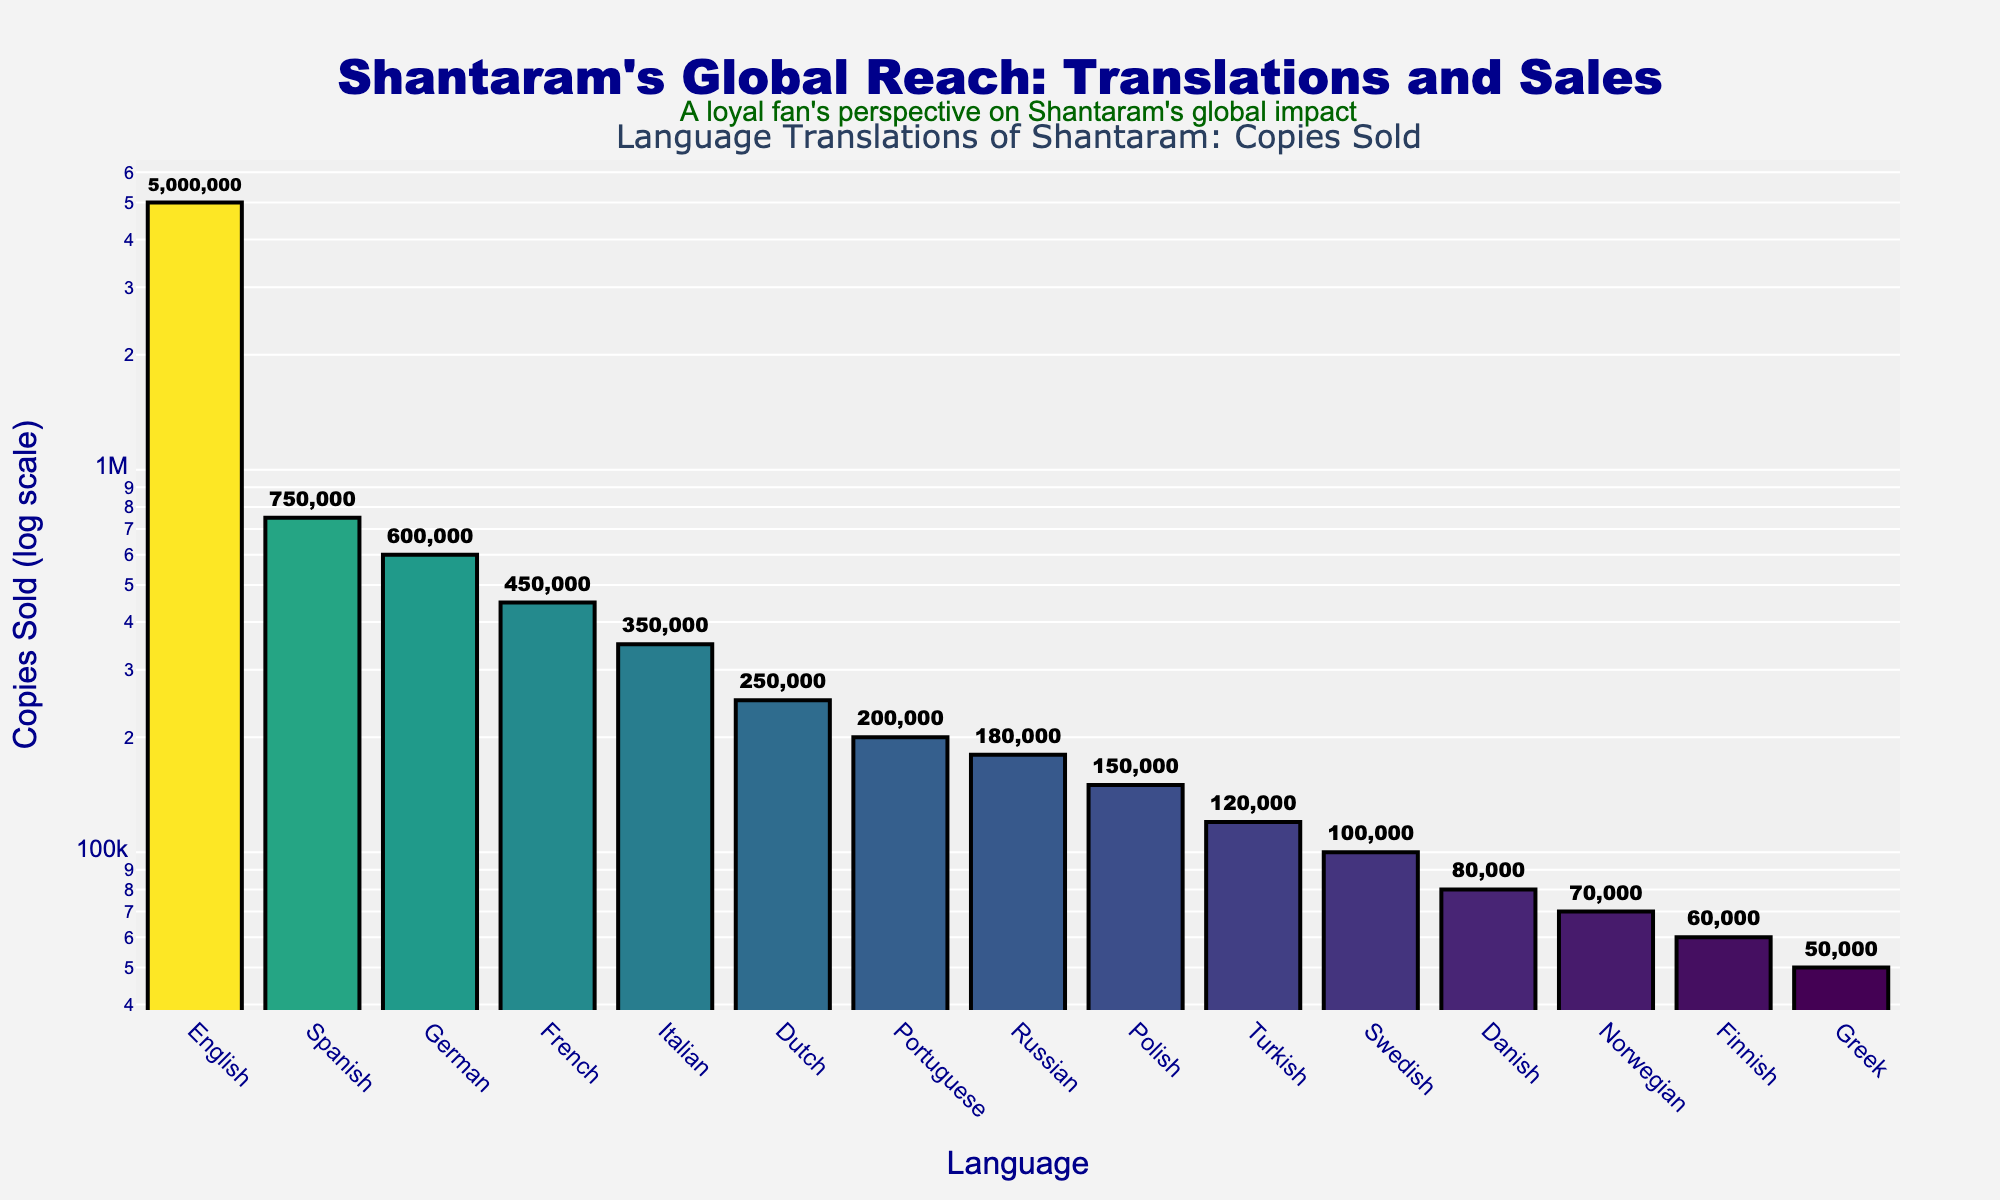What language translation of Shantaram sold the most copies? Look for the bar with the greatest height in the chart and identify the corresponding language.
Answer: English Which language translation sold the least copies? Identify the bar with the shortest height and note the language associated with it.
Answer: Greek How many more copies did the Spanish translation sell compared to the Russian translation? Find the height of the Spanish and Russian bars and subtract the Russian figure from the Spanish figure: 750,000 - 180,000.
Answer: 570,000 What is the total number of copies sold across the top three languages? Sum the copies sold in the top three bars: English (5,000,000), Spanish (750,000), and German (600,000). Calculate 5,000,000 + 750,000 + 600,000.
Answer: 6,350,000 Between Italian and Portuguese translations, which sold more copies, and by how much? Compare the heights of the Italian and Portuguese bars. Italian sold 350,000 copies, and Portuguese sold 200,000 copies. Subtract Portuguese from Italian: 350,000 - 200,000.
Answer: Italian by 150,000 What’s the average number of copies sold for the translations in languages other than English? Sum the copies sold for all languages except English and divide by the number of those languages (14 languages). (5,000,000 excluded, total for others = 750,000 + 600,000 + 450,000 + 350,000 + 250,000 + 200,000 + 180,000 + 150,000 + 120,000 + 100,000 + 80,000 + 70,000 + 60,000 + 50,000 = 3,410,000). Now, 3,410,000 / 14.
Answer: 243,571 What is the median number of copies sold for all language translations? Arrange the number of copies sold in ascending order and find the middle value. With 15 data points, the median will be the 8th value once sorted.
Answer: 180,000 Which language translations sold between 100,000 and 300,000 copies? Identify the bars whose heights correspond to a value in this range. The translations are Dutch, Portuguese, Russian, Polish, and Turkish.
Answer: Dutch, Portuguese, Russian, Polish, Turkish Assuming a new language translation sold 90,000 copies, where would it rank among the existing translations? Compare 90,000 copies with the existing data. Bars for Swedish (100,000) and Danish (80,000) show it falls between these two.
Answer: 11th 